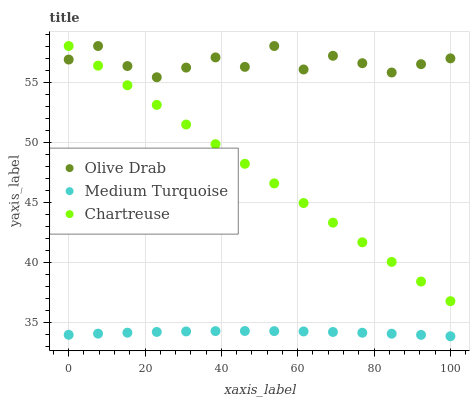Does Medium Turquoise have the minimum area under the curve?
Answer yes or no. Yes. Does Olive Drab have the maximum area under the curve?
Answer yes or no. Yes. Does Olive Drab have the minimum area under the curve?
Answer yes or no. No. Does Medium Turquoise have the maximum area under the curve?
Answer yes or no. No. Is Chartreuse the smoothest?
Answer yes or no. Yes. Is Olive Drab the roughest?
Answer yes or no. Yes. Is Medium Turquoise the smoothest?
Answer yes or no. No. Is Medium Turquoise the roughest?
Answer yes or no. No. Does Medium Turquoise have the lowest value?
Answer yes or no. Yes. Does Olive Drab have the lowest value?
Answer yes or no. No. Does Olive Drab have the highest value?
Answer yes or no. Yes. Does Medium Turquoise have the highest value?
Answer yes or no. No. Is Medium Turquoise less than Chartreuse?
Answer yes or no. Yes. Is Olive Drab greater than Medium Turquoise?
Answer yes or no. Yes. Does Olive Drab intersect Chartreuse?
Answer yes or no. Yes. Is Olive Drab less than Chartreuse?
Answer yes or no. No. Is Olive Drab greater than Chartreuse?
Answer yes or no. No. Does Medium Turquoise intersect Chartreuse?
Answer yes or no. No. 